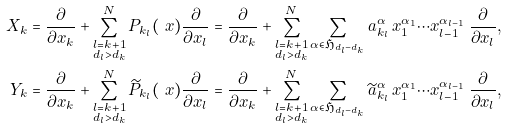Convert formula to latex. <formula><loc_0><loc_0><loc_500><loc_500>X _ { k } & = \frac { \partial } { \partial x _ { k } } + \sum _ { \substack { l = k + 1 \\ d _ { l } > d _ { k } } } ^ { N } P _ { k _ { l } } ( \ x ) \frac { \partial } { \partial x _ { l } } = \frac { \partial } { \partial x _ { k } } + \sum _ { \substack { l = k + 1 \\ d _ { l } > d _ { k } } } ^ { N } \sum _ { \alpha \in \mathfrak H _ { d _ { l } - d _ { k } } } a ^ { \alpha } _ { k _ { l } } \, x _ { 1 } ^ { \alpha _ { 1 } } \cdots x _ { l - 1 } ^ { \alpha _ { l - 1 } } \, \frac { \partial } { \partial x _ { l } } , \\ Y _ { k } & = \frac { \partial } { \partial x _ { k } } + \sum _ { \substack { l = k + 1 \\ d _ { l } > d _ { k } } } ^ { N } \widetilde { P } _ { k _ { l } } ( \ x ) \frac { \partial } { \partial x _ { l } } = \frac { \partial } { \partial x _ { k } } + \sum _ { \substack { l = k + 1 \\ d _ { l } > d _ { k } } } ^ { N } \sum _ { \alpha \in \mathfrak H _ { d _ { l } - d _ { k } } } \widetilde { a } ^ { \alpha } _ { k _ { l } } \, x _ { 1 } ^ { \alpha _ { 1 } } \cdots x _ { l - 1 } ^ { \alpha _ { l - 1 } } \, \frac { \partial } { \partial x _ { l } } ,</formula> 